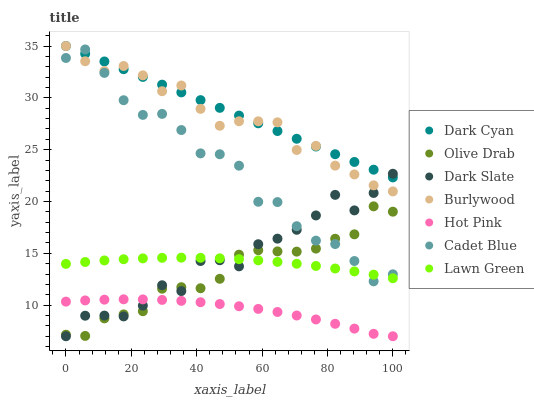Does Hot Pink have the minimum area under the curve?
Answer yes or no. Yes. Does Dark Cyan have the maximum area under the curve?
Answer yes or no. Yes. Does Cadet Blue have the minimum area under the curve?
Answer yes or no. No. Does Cadet Blue have the maximum area under the curve?
Answer yes or no. No. Is Dark Cyan the smoothest?
Answer yes or no. Yes. Is Dark Slate the roughest?
Answer yes or no. Yes. Is Cadet Blue the smoothest?
Answer yes or no. No. Is Cadet Blue the roughest?
Answer yes or no. No. Does Hot Pink have the lowest value?
Answer yes or no. Yes. Does Cadet Blue have the lowest value?
Answer yes or no. No. Does Dark Cyan have the highest value?
Answer yes or no. Yes. Does Cadet Blue have the highest value?
Answer yes or no. No. Is Olive Drab less than Burlywood?
Answer yes or no. Yes. Is Dark Cyan greater than Lawn Green?
Answer yes or no. Yes. Does Olive Drab intersect Cadet Blue?
Answer yes or no. Yes. Is Olive Drab less than Cadet Blue?
Answer yes or no. No. Is Olive Drab greater than Cadet Blue?
Answer yes or no. No. Does Olive Drab intersect Burlywood?
Answer yes or no. No. 